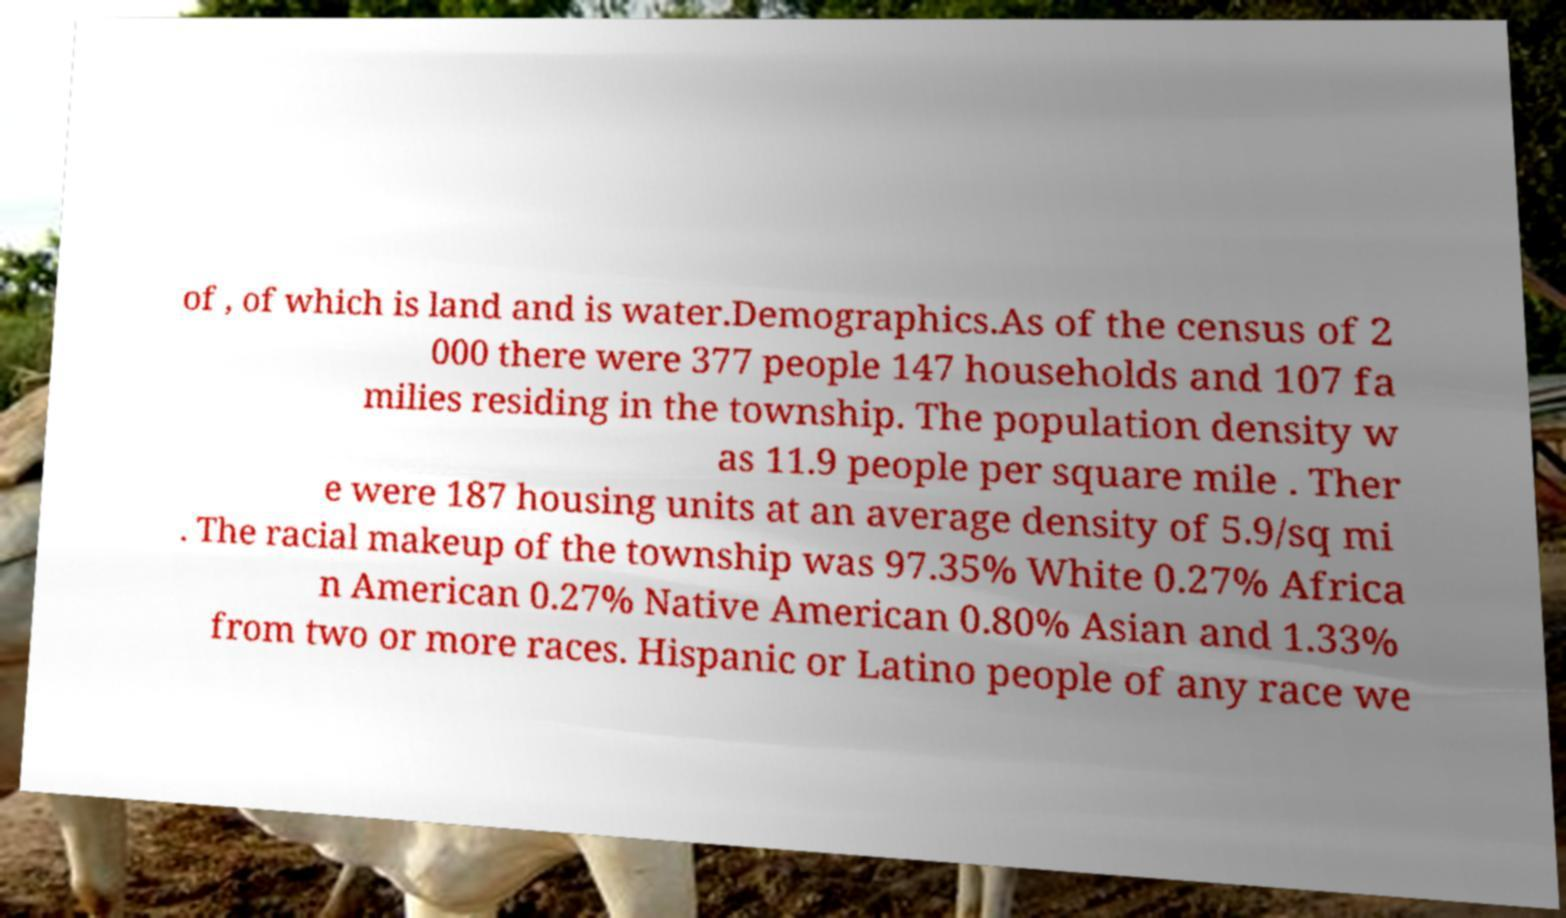Can you read and provide the text displayed in the image?This photo seems to have some interesting text. Can you extract and type it out for me? of , of which is land and is water.Demographics.As of the census of 2 000 there were 377 people 147 households and 107 fa milies residing in the township. The population density w as 11.9 people per square mile . Ther e were 187 housing units at an average density of 5.9/sq mi . The racial makeup of the township was 97.35% White 0.27% Africa n American 0.27% Native American 0.80% Asian and 1.33% from two or more races. Hispanic or Latino people of any race we 